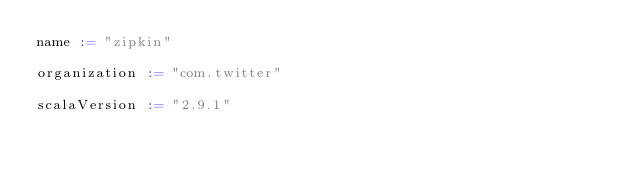Convert code to text. <code><loc_0><loc_0><loc_500><loc_500><_Scala_>name := "zipkin"

organization := "com.twitter"

scalaVersion := "2.9.1"

</code> 